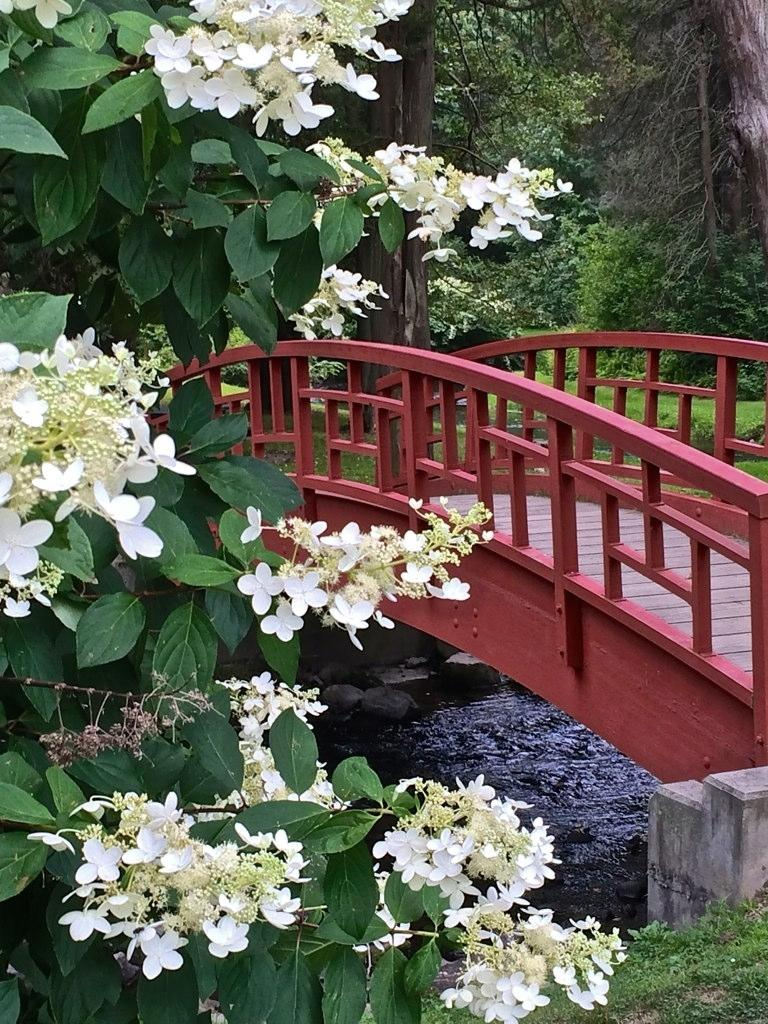What types of vegetation can be seen in the front of the image? There are flowers and plants in the front of the image. What is located in the center of the image? There is water and a bridge in the center of the image. What can be seen in the background of the image? There are trees in the background of the image. What type of ground is visible in the image? There is grass on the ground in the image. Can you tell me how many crackers are floating in the water in the image? There are no crackers present in the image; it features water and a bridge. What country is depicted in the image? The image does not depict a specific country; it shows a natural scene with water, a bridge, and vegetation. 